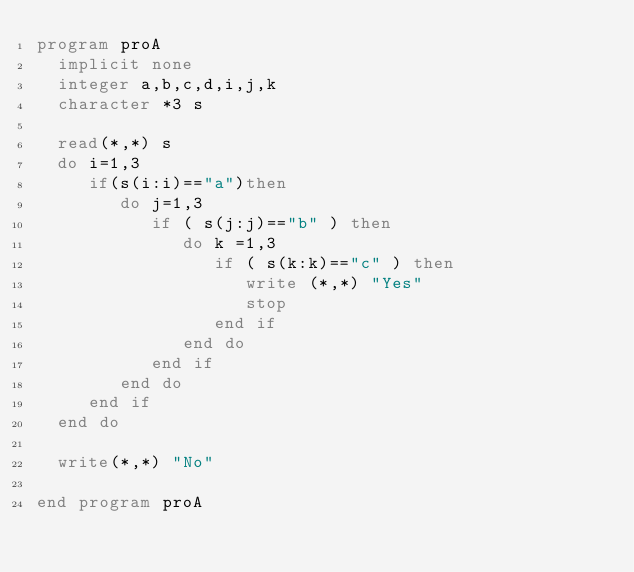<code> <loc_0><loc_0><loc_500><loc_500><_FORTRAN_>program proA
  implicit none
  integer a,b,c,d,i,j,k
  character *3 s

  read(*,*) s
  do i=1,3
     if(s(i:i)=="a")then
        do j=1,3
           if ( s(j:j)=="b" ) then
              do k =1,3
                 if ( s(k:k)=="c" ) then
                    write (*,*) "Yes"
                    stop                    
                 end if
              end do
           end if
        end do
     end if
  end do

  write(*,*) "No"
  
end program proA
</code> 